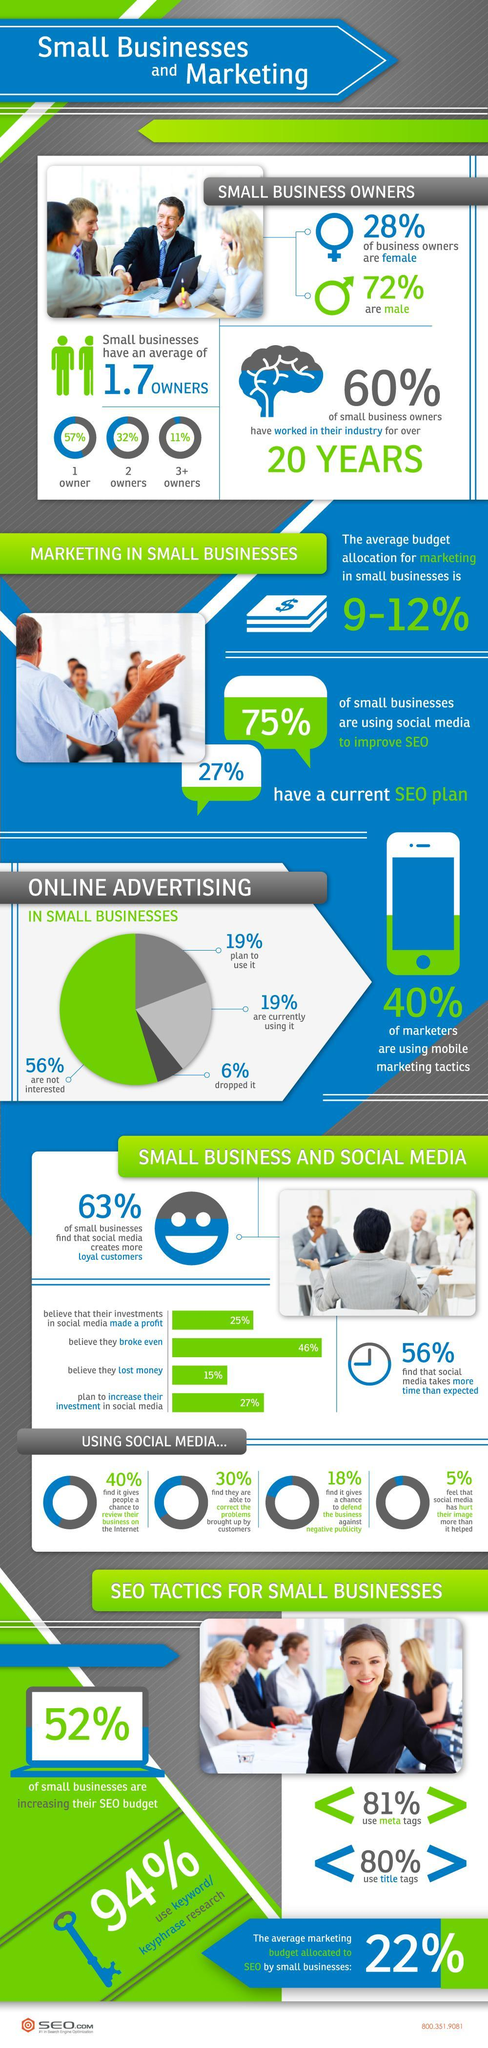How much budget is allocated for marketing?
Answer the question with a short phrase. 9-12% What do 56% do regarding online advertising? not interested What percentage of people neither made profit nor loss? 46% How many owners does maximum small businesses have? 1 How many women own small businesses? 28% What percentage of small businesses do not use social media to improve SEO? 25% What percentage of businesses use SEO for marketing? 27% 